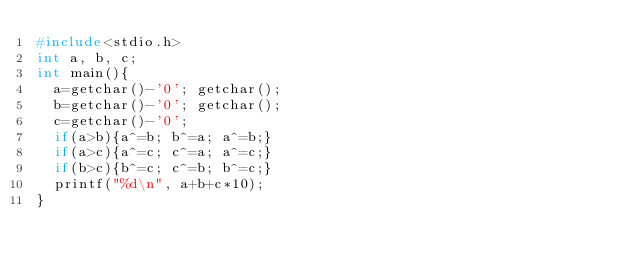<code> <loc_0><loc_0><loc_500><loc_500><_C_>#include<stdio.h>
int a, b, c;
int main(){
  a=getchar()-'0'; getchar();
  b=getchar()-'0'; getchar();
  c=getchar()-'0';
  if(a>b){a^=b; b^=a; a^=b;}
  if(a>c){a^=c; c^=a; a^=c;}
  if(b>c){b^=c; c^=b; b^=c;}
  printf("%d\n", a+b+c*10);
}
</code> 